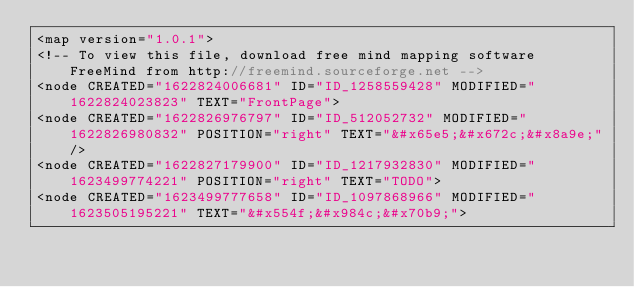Convert code to text. <code><loc_0><loc_0><loc_500><loc_500><_ObjectiveC_><map version="1.0.1">
<!-- To view this file, download free mind mapping software FreeMind from http://freemind.sourceforge.net -->
<node CREATED="1622824006681" ID="ID_1258559428" MODIFIED="1622824023823" TEXT="FrontPage">
<node CREATED="1622826976797" ID="ID_512052732" MODIFIED="1622826980832" POSITION="right" TEXT="&#x65e5;&#x672c;&#x8a9e;"/>
<node CREATED="1622827179900" ID="ID_1217932830" MODIFIED="1623499774221" POSITION="right" TEXT="TODO">
<node CREATED="1623499777658" ID="ID_1097868966" MODIFIED="1623505195221" TEXT="&#x554f;&#x984c;&#x70b9;"></code> 